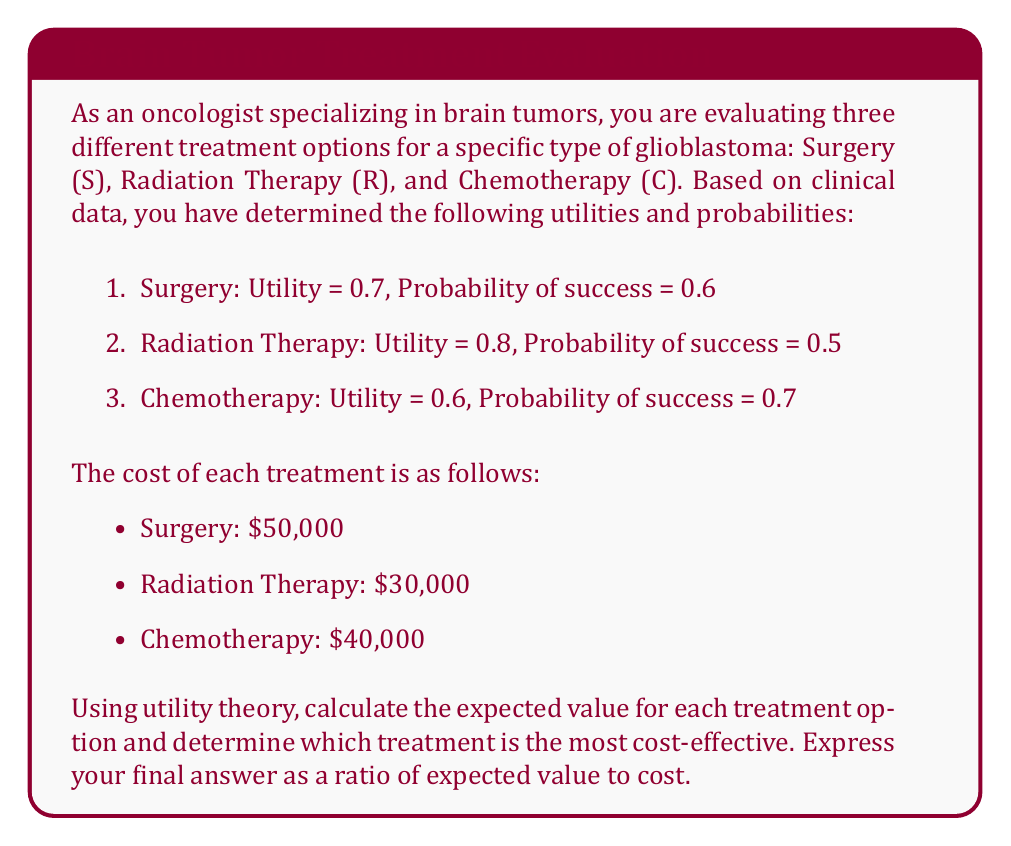Give your solution to this math problem. To solve this problem, we'll follow these steps:

1. Calculate the expected utility for each treatment option
2. Calculate the expected value (EV) for each treatment option
3. Determine the cost-effectiveness ratio for each option
4. Compare the ratios to find the most cost-effective treatment

Step 1: Calculate the expected utility

The expected utility is calculated by multiplying the utility of the treatment by the probability of success.

For Surgery (S):
$$EU_S = 0.7 \times 0.6 = 0.42$$

For Radiation Therapy (R):
$$EU_R = 0.8 \times 0.5 = 0.40$$

For Chemotherapy (C):
$$EU_C = 0.6 \times 0.7 = 0.42$$

Step 2: Calculate the expected value (EV)

To convert the expected utility to a monetary value, we'll assume a willingness-to-pay threshold of $100,000 per quality-adjusted life year (QALY). This is a common benchmark in health economics.

For Surgery:
$$EV_S = 0.42 \times \$100,000 = \$42,000$$

For Radiation Therapy:
$$EV_R = 0.40 \times \$100,000 = \$40,000$$

For Chemotherapy:
$$EV_C = 0.42 \times \$100,000 = \$42,000$$

Step 3: Determine the cost-effectiveness ratio

The cost-effectiveness ratio is calculated by dividing the expected value by the cost of the treatment.

For Surgery:
$$CE_S = \frac{\$42,000}{\$50,000} = 0.84$$

For Radiation Therapy:
$$CE_R = \frac{\$40,000}{\$30,000} = 1.33$$

For Chemotherapy:
$$CE_C = \frac{\$42,000}{\$40,000} = 1.05$$

Step 4: Compare the ratios

The highest ratio indicates the most cost-effective treatment. In this case, Radiation Therapy has the highest ratio at 1.33, making it the most cost-effective option.
Answer: The most cost-effective treatment is Radiation Therapy, with a cost-effectiveness ratio of 1.33. 